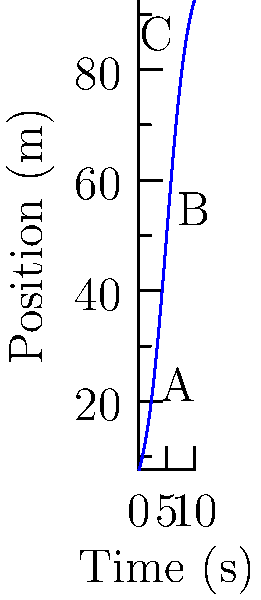The position-time graph above represents a 100-meter dash. Points A, B, and C correspond to times 2s, 5s, and 8s respectively. At which point is the instantaneous acceleration of the runner the highest? To determine the point of highest instantaneous acceleration, we need to analyze the rate of change of velocity (which is itself the rate of change of position) at each point. Here's how we can approach this:

1) Instantaneous velocity is given by the slope of the tangent line to the position-time curve at any given point.

2) Acceleration is the rate of change of velocity, which corresponds to the rate of change of the slope of the tangent line.

3) Analyzing the curve:
   - At point A (2s): The curve is starting to steepen, indicating increasing velocity and positive acceleration.
   - At point B (5s): The curve is at its steepest point, indicating maximum velocity but near-zero acceleration.
   - At point C (8s): The curve is leveling off, indicating decreasing velocity and negative acceleration.

4) The instantaneous acceleration is highest where the change in the slope of the tangent line is greatest.

5) This occurs at point A, where the curve transitions from nearly flat to steep, indicating a rapid increase in velocity.

Therefore, the instantaneous acceleration is highest at point A.
Answer: Point A 